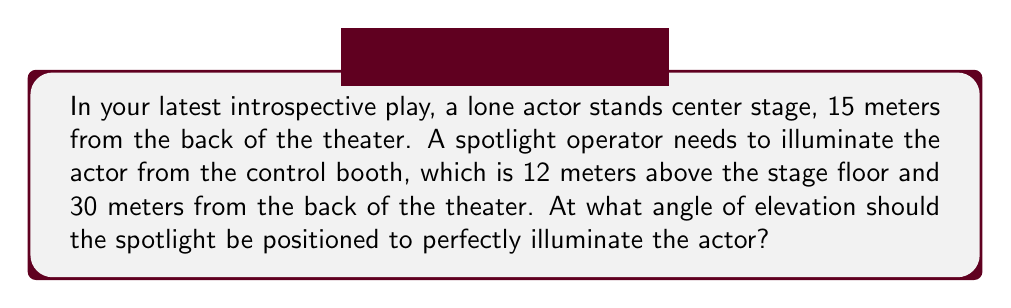Help me with this question. Let's approach this step-by-step:

1) First, let's visualize the problem:

[asy]
import geometry;

size(200);

pair A = (0,0);   // Actor's position
pair B = (15,12); // Spotlight position
pair C = (15,0);  // Point directly below spotlight

draw(A--B--C--A);
draw(B--C,dashed);

label("Actor", A, SW);
label("Spotlight", B, NE);
label("15m", (A+C)/2, S);
label("12m", (B+C)/2, E);
label("30m", (A+B)/2, NW);
label("$\theta$", B, SE);

markangle(A,B,C,radius=15);
[/asy]

2) We can see that this forms a right-angled triangle. We need to find the angle $\theta$.

3) We can use the tangent function to find this angle. The tangent of an angle in a right-angled triangle is the opposite side divided by the adjacent side.

4) In this case:
   - The opposite side is the height of the spotlight above the stage: 12 meters
   - The adjacent side is the horizontal distance from the actor to the spotlight: 30 - 15 = 15 meters

5) We can express this as:

   $$\tan(\theta) = \frac{\text{opposite}}{\text{adjacent}} = \frac{12}{15}$$

6) To find $\theta$, we need to take the inverse tangent (arctan or $\tan^{-1}$) of both sides:

   $$\theta = \tan^{-1}(\frac{12}{15})$$

7) Using a calculator or computer:

   $$\theta \approx 38.66^\circ$$

Thus, the angle of elevation for the spotlight should be approximately 38.66 degrees.
Answer: $38.66^\circ$ 